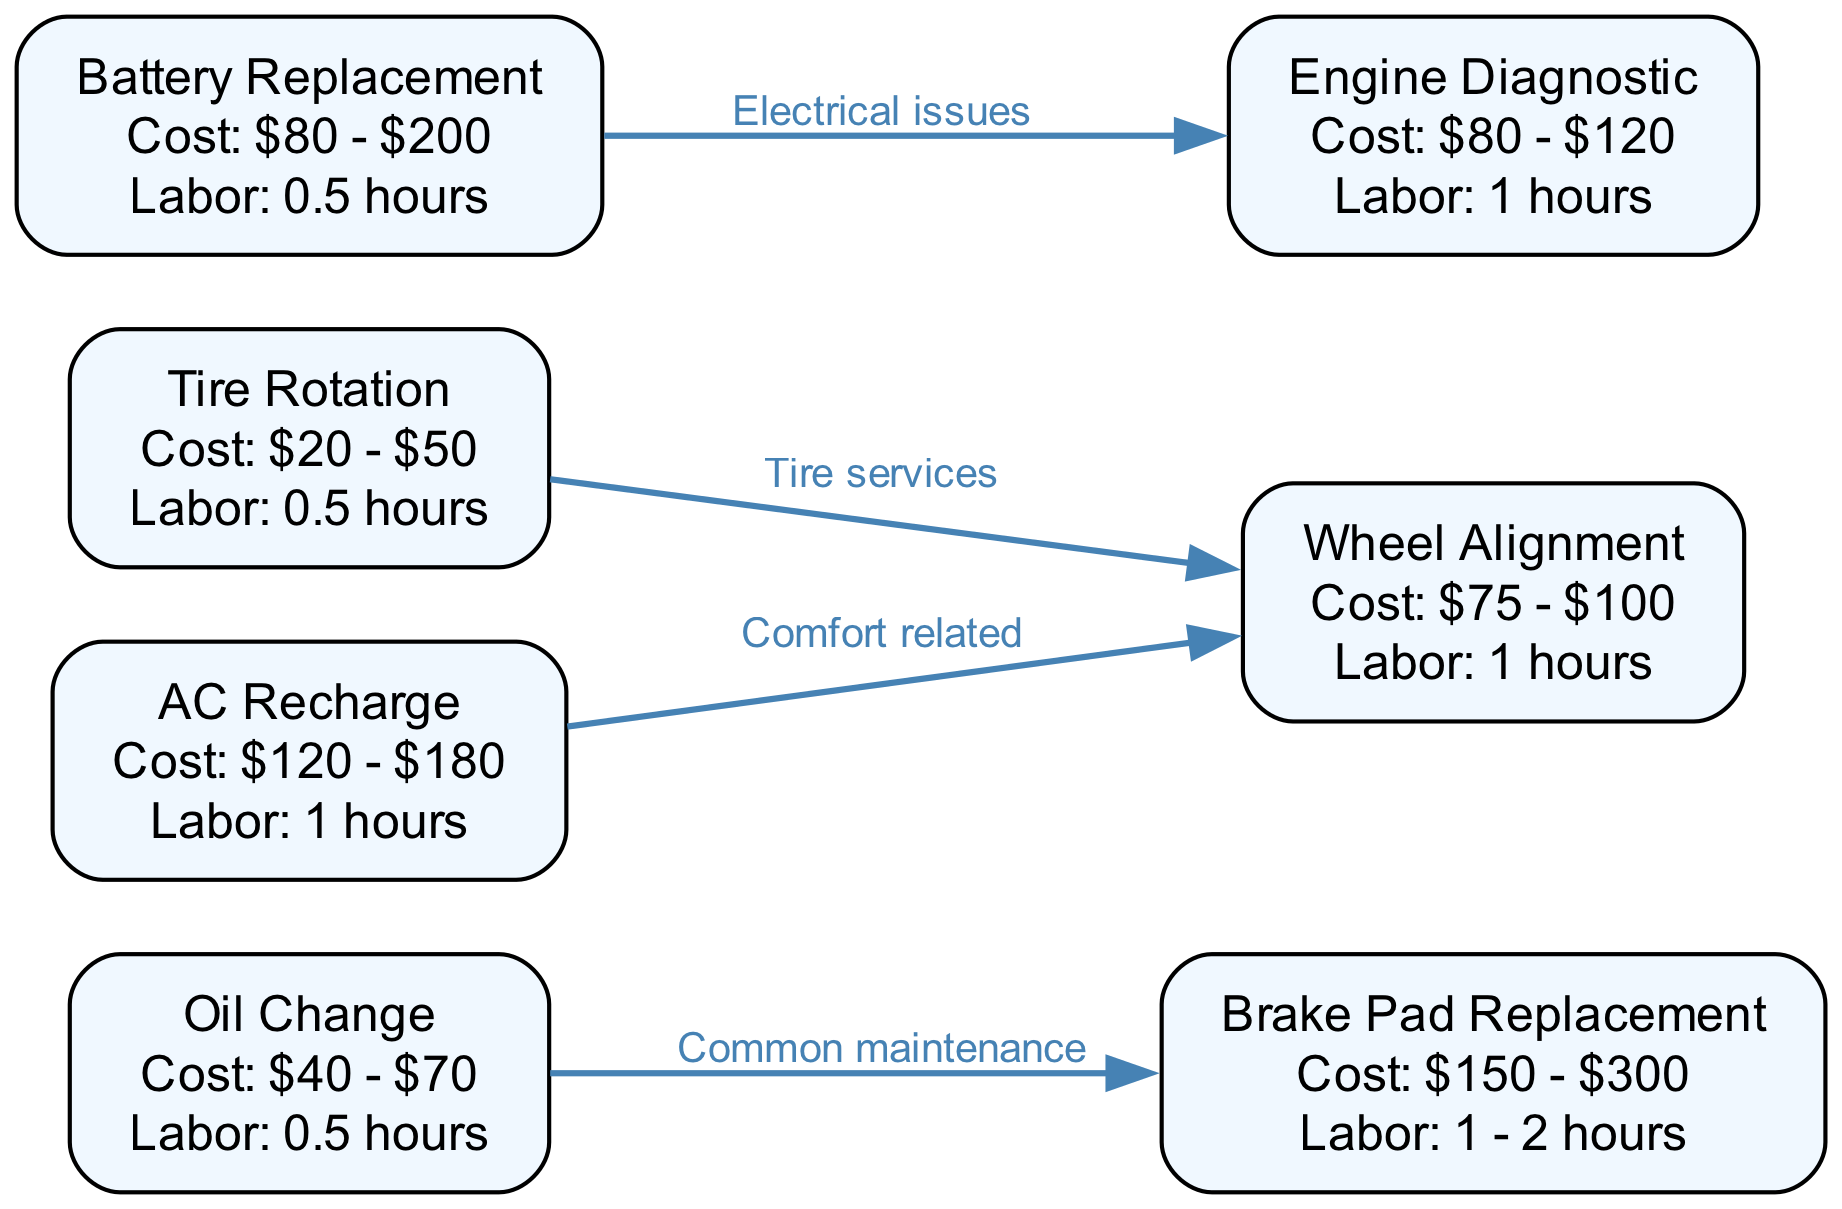What is the cost range for an Oil Change? According to the diagram, the cost range for an Oil Change is $40 - $70. This information is specified directly in the node labeled "Oil Change."
Answer: $40 - $70 How many nodes are present in the diagram? The diagram consists of 7 nodes representing different vehicle service requests. This can be counted from the nodes section of the data provided.
Answer: 7 What is the labor hour requirement for a Tire Rotation? The diagram indicates that a Tire Rotation requires 0.5 hours of labor, as detailed in the node labeled "Tire Rotation."
Answer: 0.5 Which maintenance request is connected to Brake Pad Replacement? The diagram shows that Brake Pad Replacement is commonly linked to Oil Change, as indicated by the directed edge labeled "Common maintenance."
Answer: Oil Change If an AC Recharge costs between $120 and $180, what is the average cost? To find the average cost, add the low end ($120) to the high end ($180) and divide by 2. The calculation is (120 + 180) / 2 = 150. This average is derived from the cost range specified in the node for AC Recharge.
Answer: $150 What type of issues is Battery Replacement linked to? Battery Replacement is associated with electrical issues, as shown in the diagram with the edge labeled "Electrical issues" connecting Battery Replacement to Engine Diagnostic.
Answer: Electrical issues Is there a connection between Tire Rotation and Wheel Alignment? Yes, Tire Rotation is connected to Wheel Alignment through the edge labeled "Tire services," indicating a service relationship between them in the context of tire maintenance.
Answer: Yes Which service request has the highest potential cost? The service request with the highest potential cost, according to the diagram, is Brake Pad Replacement, with a cost range of $150 - $300.
Answer: Brake Pad Replacement 